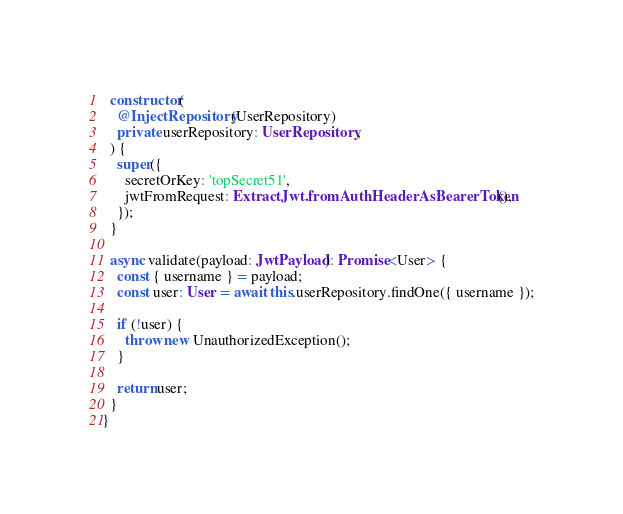Convert code to text. <code><loc_0><loc_0><loc_500><loc_500><_TypeScript_>  constructor(
    @InjectRepository(UserRepository)
    private userRepository: UserRepository,
  ) {
    super({
      secretOrKey: 'topSecret51',
      jwtFromRequest: ExtractJwt.fromAuthHeaderAsBearerToken(),
    });
  }

  async validate(payload: JwtPayload): Promise<User> {
    const { username } = payload;
    const user: User = await this.userRepository.findOne({ username });

    if (!user) {
      throw new UnauthorizedException();
    }

    return user;
  }
}
</code> 